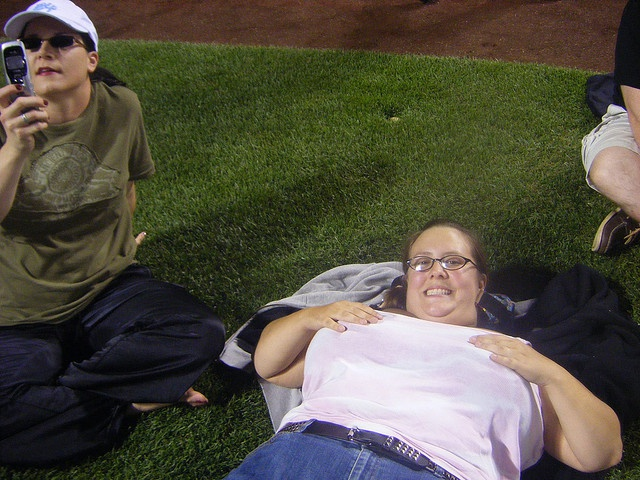Describe the objects in this image and their specific colors. I can see people in black, darkgreen, and gray tones, people in black, lavender, tan, and blue tones, people in black, darkgray, and tan tones, and cell phone in black, navy, gray, and darkgray tones in this image. 